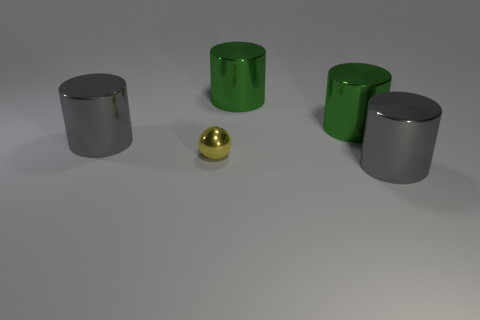Is there a tiny yellow cube made of the same material as the yellow ball? Upon examining the image, it can be confirmed that there is no yellow cube present. There is, however, a small yellow ball that appears smooth and reflective, suggesting it's made of a material like polished metal or plastic. No other objects of a similar material in a cubic shape are visible. 